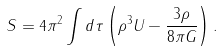Convert formula to latex. <formula><loc_0><loc_0><loc_500><loc_500>S = 4 \pi ^ { 2 } \int d \tau \left ( \rho ^ { 3 } U - \frac { 3 \rho } { 8 \pi G } \right ) .</formula> 